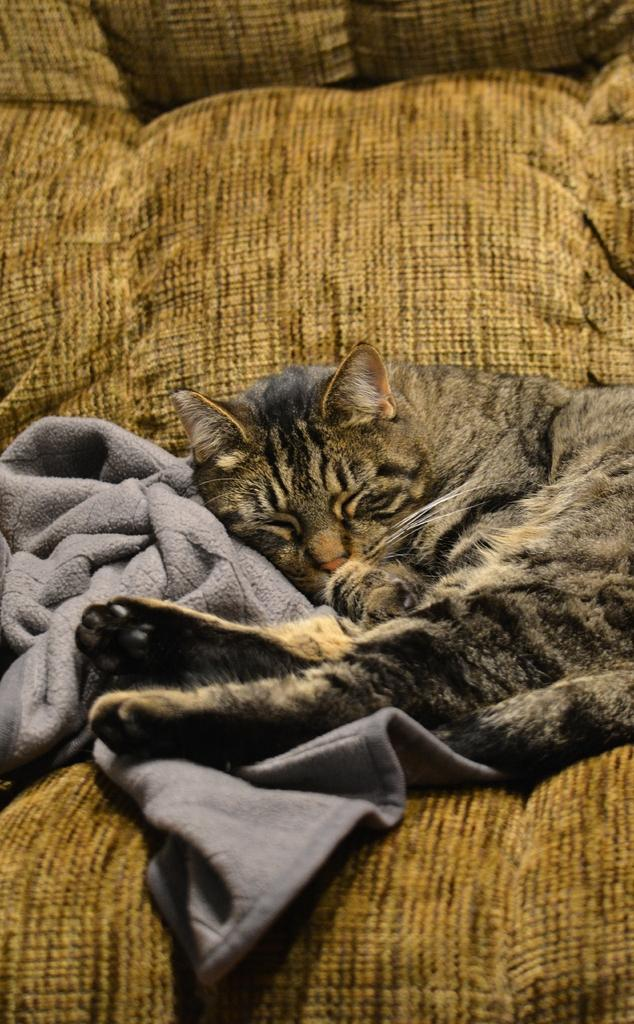What type of animal is in the picture? There is a cat in the picture. What is the cat doing in the picture? The cat is sleeping on a sofa. What can be seen on the left side of the image? There is a towel on the left side of the image. What type of berry is the cat holding in its paw in the image? There is no berry present in the image, and the cat is not holding anything in its paw. 